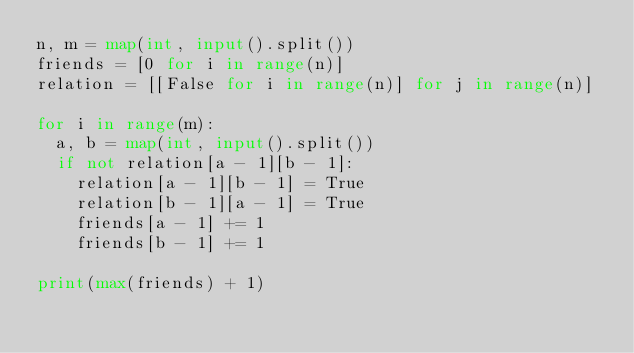Convert code to text. <code><loc_0><loc_0><loc_500><loc_500><_Python_>n, m = map(int, input().split())
friends = [0 for i in range(n)]
relation = [[False for i in range(n)] for j in range(n)]

for i in range(m):
  a, b = map(int, input().split())
  if not relation[a - 1][b - 1]:
    relation[a - 1][b - 1] = True
    relation[b - 1][a - 1] = True
    friends[a - 1] += 1
    friends[b - 1] += 1

print(max(friends) + 1)</code> 